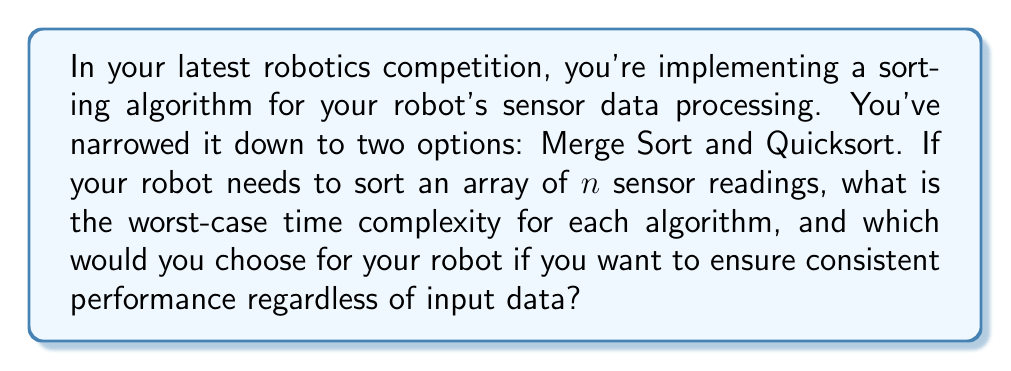What is the answer to this math problem? Let's analyze the time complexity of both Merge Sort and Quicksort:

1. Merge Sort:
   Merge Sort follows a divide-and-conquer approach. It consistently divides the array into two halves, sorts them recursively, and then merges the sorted halves.

   Time complexity analysis:
   - Dividing: $O(1)$
   - Recursion: $T(n) = 2T(n/2)$
   - Merging: $O(n)$

   Using the master theorem, we can determine that the overall time complexity of Merge Sort is:

   $$T(n) = O(n \log n)$$

   This time complexity holds for all cases: best, average, and worst.

2. Quicksort:
   Quicksort also uses a divide-and-conquer strategy, but its performance can vary based on the choice of pivot and the input data.

   Best and Average case:
   When the pivot divides the array into roughly equal halves, the time complexity is:

   $$T(n) = O(n \log n)$$

   Worst case:
   The worst case occurs when the pivot is always the smallest or largest element, leading to unbalanced partitions. In this case, the time complexity becomes:

   $$T(n) = O(n^2)$$

For robotics applications, consistent performance is often crucial. While Quicksort can be faster in practice due to its in-place sorting and good cache performance, its worst-case scenario could lead to unexpected delays in processing sensor data.

Merge Sort, on the other hand, guarantees $O(n \log n)$ time complexity in all cases, providing a more predictable and stable performance for your robot's sensor data processing.

Therefore, for ensuring consistent performance regardless of input data, Merge Sort would be the better choice for your robotics application.
Answer: Merge Sort: $O(n \log n)$ worst-case time complexity
Quicksort: $O(n^2)$ worst-case time complexity
Choose Merge Sort for consistent $O(n \log n)$ performance in robotics applications. 